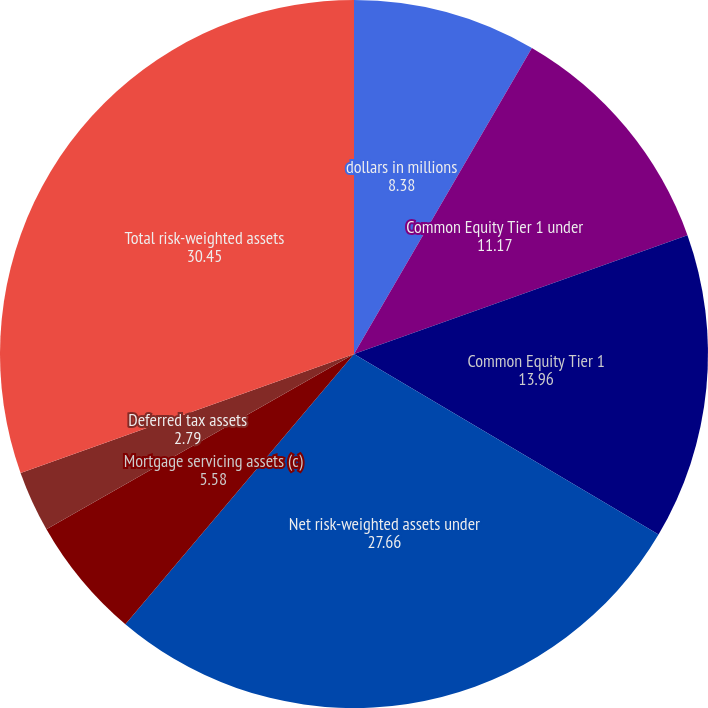Convert chart. <chart><loc_0><loc_0><loc_500><loc_500><pie_chart><fcel>dollars in millions<fcel>Common Equity Tier 1 under<fcel>Common Equity Tier 1<fcel>Net risk-weighted assets under<fcel>Mortgage servicing assets (c)<fcel>Deferred tax assets<fcel>Total risk-weighted assets<fcel>Common Equity Tier 1 ratio<nl><fcel>8.38%<fcel>11.17%<fcel>13.96%<fcel>27.66%<fcel>5.58%<fcel>2.79%<fcel>30.45%<fcel>0.0%<nl></chart> 